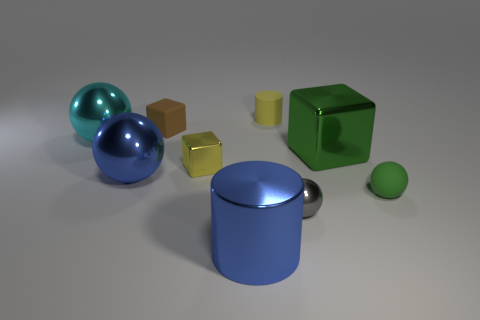Subtract 1 spheres. How many spheres are left? 3 Subtract all red balls. Subtract all brown cylinders. How many balls are left? 4 Subtract all spheres. How many objects are left? 5 Add 8 big shiny cylinders. How many big shiny cylinders exist? 9 Subtract 1 blue cylinders. How many objects are left? 8 Subtract all brown metallic objects. Subtract all small cylinders. How many objects are left? 8 Add 3 green balls. How many green balls are left? 4 